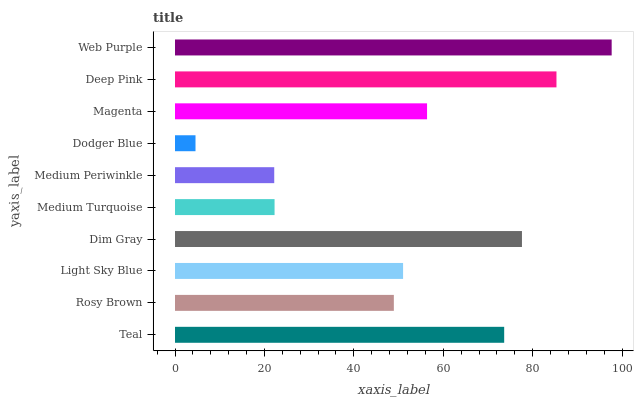Is Dodger Blue the minimum?
Answer yes or no. Yes. Is Web Purple the maximum?
Answer yes or no. Yes. Is Rosy Brown the minimum?
Answer yes or no. No. Is Rosy Brown the maximum?
Answer yes or no. No. Is Teal greater than Rosy Brown?
Answer yes or no. Yes. Is Rosy Brown less than Teal?
Answer yes or no. Yes. Is Rosy Brown greater than Teal?
Answer yes or no. No. Is Teal less than Rosy Brown?
Answer yes or no. No. Is Magenta the high median?
Answer yes or no. Yes. Is Light Sky Blue the low median?
Answer yes or no. Yes. Is Dim Gray the high median?
Answer yes or no. No. Is Dim Gray the low median?
Answer yes or no. No. 